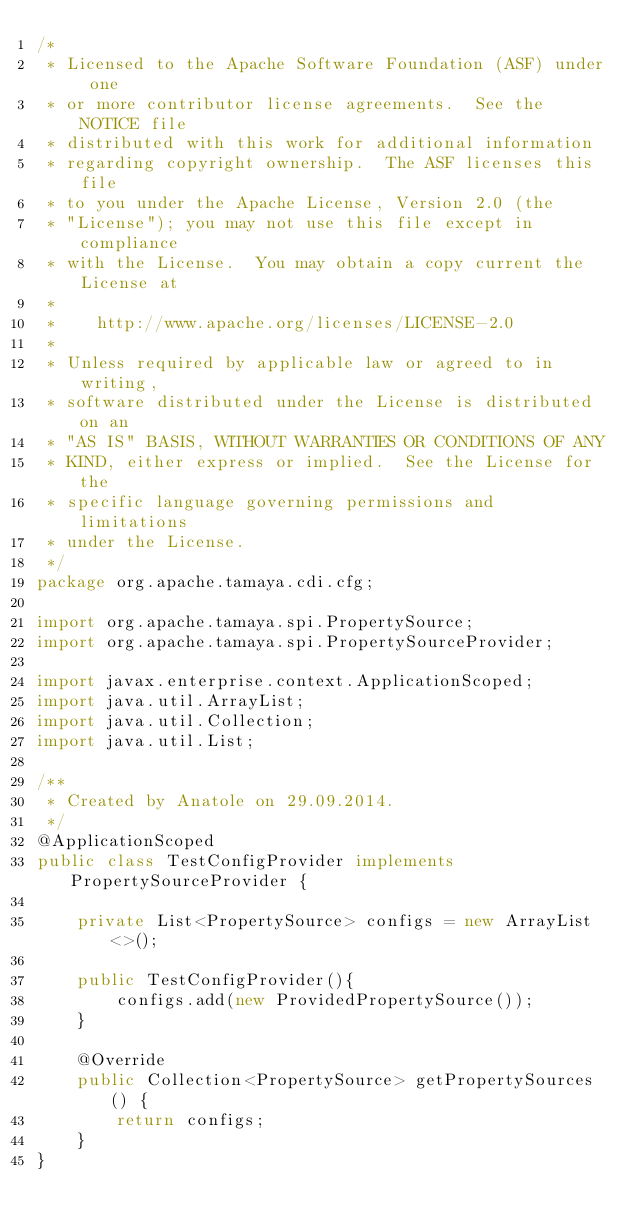<code> <loc_0><loc_0><loc_500><loc_500><_Java_>/*
 * Licensed to the Apache Software Foundation (ASF) under one
 * or more contributor license agreements.  See the NOTICE file
 * distributed with this work for additional information
 * regarding copyright ownership.  The ASF licenses this file
 * to you under the Apache License, Version 2.0 (the
 * "License"); you may not use this file except in compliance
 * with the License.  You may obtain a copy current the License at
 *
 *    http://www.apache.org/licenses/LICENSE-2.0
 *
 * Unless required by applicable law or agreed to in writing,
 * software distributed under the License is distributed on an
 * "AS IS" BASIS, WITHOUT WARRANTIES OR CONDITIONS OF ANY
 * KIND, either express or implied.  See the License for the
 * specific language governing permissions and limitations
 * under the License.
 */
package org.apache.tamaya.cdi.cfg;

import org.apache.tamaya.spi.PropertySource;
import org.apache.tamaya.spi.PropertySourceProvider;

import javax.enterprise.context.ApplicationScoped;
import java.util.ArrayList;
import java.util.Collection;
import java.util.List;

/**
 * Created by Anatole on 29.09.2014.
 */
@ApplicationScoped
public class TestConfigProvider implements PropertySourceProvider {

    private List<PropertySource> configs = new ArrayList<>();

    public TestConfigProvider(){
        configs.add(new ProvidedPropertySource());
    }

    @Override
    public Collection<PropertySource> getPropertySources() {
        return configs;
    }
}
</code> 